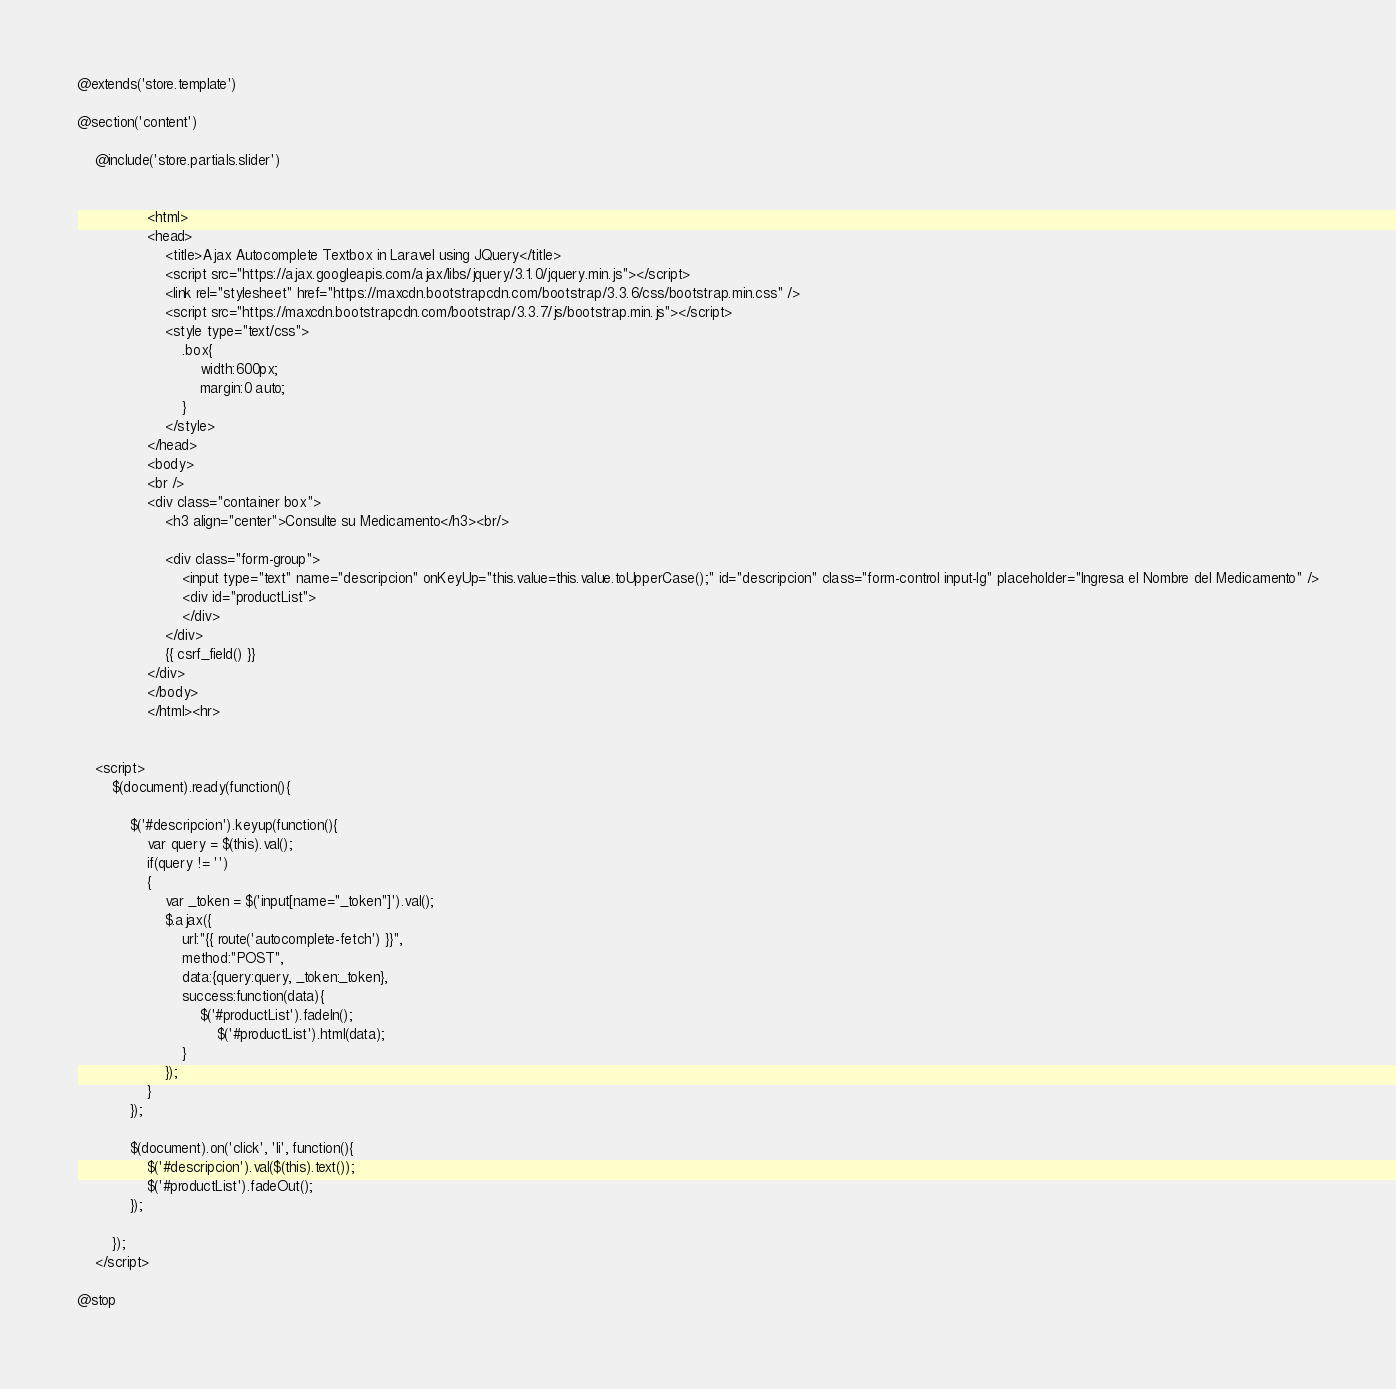Convert code to text. <code><loc_0><loc_0><loc_500><loc_500><_PHP_>@extends('store.template')

@section('content')

    @include('store.partials.slider')


                <html>
                <head>
                    <title>Ajax Autocomplete Textbox in Laravel using JQuery</title>
                    <script src="https://ajax.googleapis.com/ajax/libs/jquery/3.1.0/jquery.min.js"></script>
                    <link rel="stylesheet" href="https://maxcdn.bootstrapcdn.com/bootstrap/3.3.6/css/bootstrap.min.css" />
                    <script src="https://maxcdn.bootstrapcdn.com/bootstrap/3.3.7/js/bootstrap.min.js"></script>
                    <style type="text/css">
                        .box{
                            width:600px;
                            margin:0 auto;
                        }
                    </style>
                </head>
                <body>
                <br />
                <div class="container box">
                    <h3 align="center">Consulte su Medicamento</h3><br/>

                    <div class="form-group">
                        <input type="text" name="descripcion" onKeyUp="this.value=this.value.toUpperCase();" id="descripcion" class="form-control input-lg" placeholder="Ingresa el Nombre del Medicamento" />
                        <div id="productList">
                        </div>
                    </div>
                    {{ csrf_field() }}
                </div>
                </body>
                </html><hr>


    <script>
        $(document).ready(function(){

            $('#descripcion').keyup(function(){
                var query = $(this).val();
                if(query != '')
                {
                    var _token = $('input[name="_token"]').val();
                    $.ajax({
                        url:"{{ route('autocomplete-fetch') }}",
                        method:"POST",
                        data:{query:query, _token:_token},
                        success:function(data){
                            $('#productList').fadeIn();
                                $('#productList').html(data);
                        }
                    });
                }
            });

            $(document).on('click', 'li', function(){
                $('#descripcion').val($(this).text());
                $('#productList').fadeOut();
            });

        });
    </script>

@stop</code> 